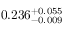Convert formula to latex. <formula><loc_0><loc_0><loc_500><loc_500>0 . 2 3 6 _ { - 0 . 0 0 9 } ^ { + 0 . 0 5 5 }</formula> 